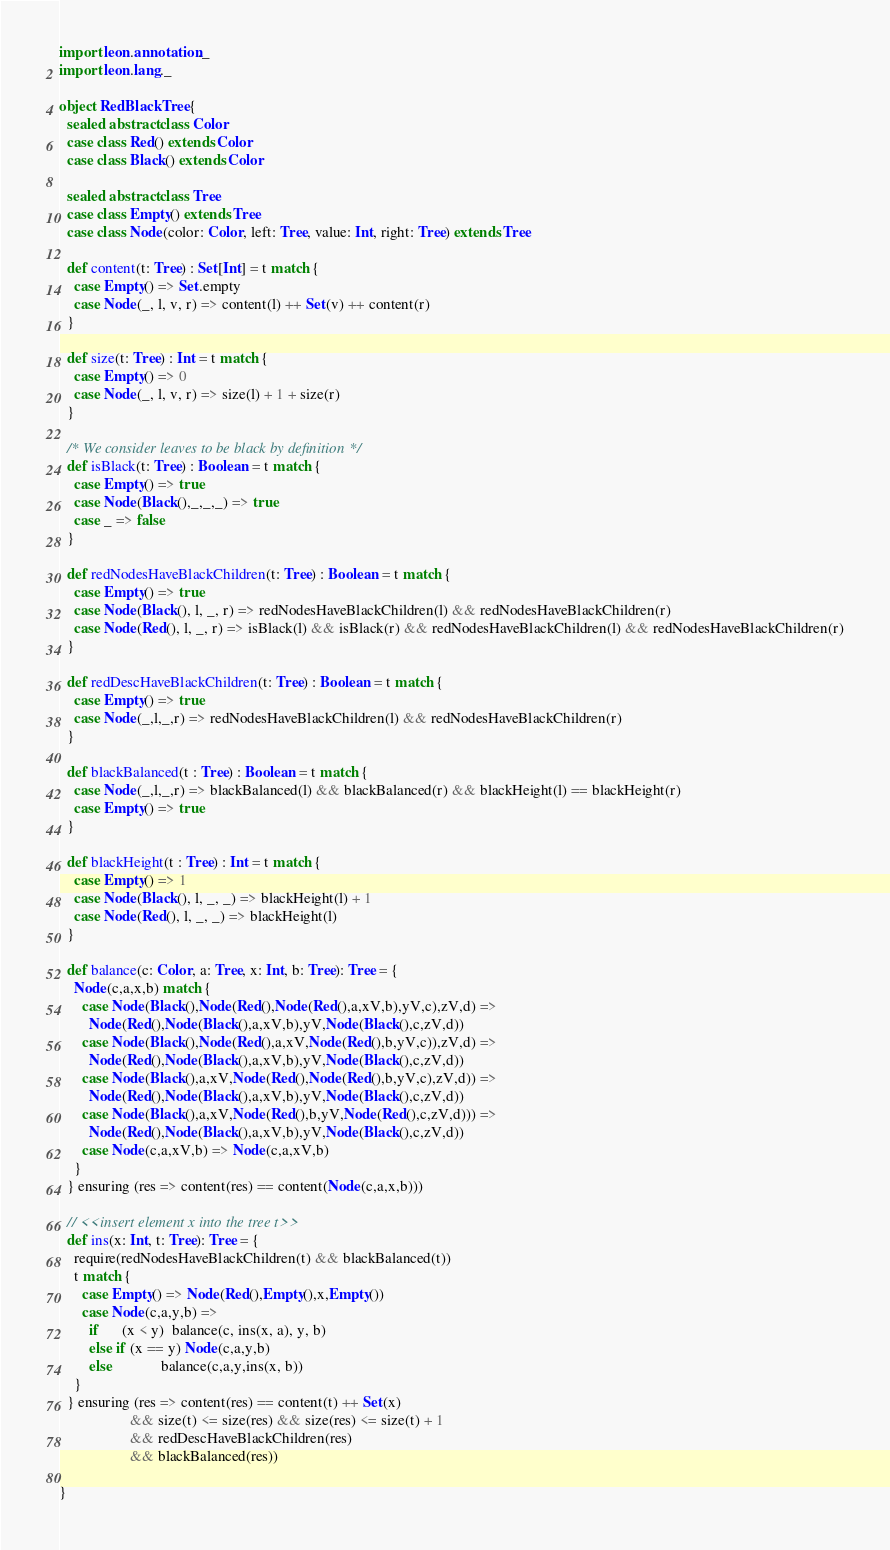<code> <loc_0><loc_0><loc_500><loc_500><_Scala_>import leon.annotation._
import leon.lang._

object RedBlackTree { 
  sealed abstract class Color
  case class Red() extends Color
  case class Black() extends Color
 
  sealed abstract class Tree
  case class Empty() extends Tree
  case class Node(color: Color, left: Tree, value: Int, right: Tree) extends Tree

  def content(t: Tree) : Set[Int] = t match {
    case Empty() => Set.empty
    case Node(_, l, v, r) => content(l) ++ Set(v) ++ content(r)
  }

  def size(t: Tree) : Int = t match {
    case Empty() => 0
    case Node(_, l, v, r) => size(l) + 1 + size(r)
  }

  /* We consider leaves to be black by definition */
  def isBlack(t: Tree) : Boolean = t match {
    case Empty() => true
    case Node(Black(),_,_,_) => true
    case _ => false
  }

  def redNodesHaveBlackChildren(t: Tree) : Boolean = t match {
    case Empty() => true
    case Node(Black(), l, _, r) => redNodesHaveBlackChildren(l) && redNodesHaveBlackChildren(r)
    case Node(Red(), l, _, r) => isBlack(l) && isBlack(r) && redNodesHaveBlackChildren(l) && redNodesHaveBlackChildren(r)
  }

  def redDescHaveBlackChildren(t: Tree) : Boolean = t match {
    case Empty() => true
    case Node(_,l,_,r) => redNodesHaveBlackChildren(l) && redNodesHaveBlackChildren(r)
  }

  def blackBalanced(t : Tree) : Boolean = t match {
    case Node(_,l,_,r) => blackBalanced(l) && blackBalanced(r) && blackHeight(l) == blackHeight(r)
    case Empty() => true
  }

  def blackHeight(t : Tree) : Int = t match {
    case Empty() => 1
    case Node(Black(), l, _, _) => blackHeight(l) + 1
    case Node(Red(), l, _, _) => blackHeight(l)
  }
  
  def balance(c: Color, a: Tree, x: Int, b: Tree): Tree = {
    Node(c,a,x,b) match {
      case Node(Black(),Node(Red(),Node(Red(),a,xV,b),yV,c),zV,d) => 
        Node(Red(),Node(Black(),a,xV,b),yV,Node(Black(),c,zV,d))
      case Node(Black(),Node(Red(),a,xV,Node(Red(),b,yV,c)),zV,d) => 
        Node(Red(),Node(Black(),a,xV,b),yV,Node(Black(),c,zV,d))
      case Node(Black(),a,xV,Node(Red(),Node(Red(),b,yV,c),zV,d)) => 
        Node(Red(),Node(Black(),a,xV,b),yV,Node(Black(),c,zV,d))
      case Node(Black(),a,xV,Node(Red(),b,yV,Node(Red(),c,zV,d))) => 
        Node(Red(),Node(Black(),a,xV,b),yV,Node(Black(),c,zV,d))
      case Node(c,a,xV,b) => Node(c,a,xV,b)
    }
  } ensuring (res => content(res) == content(Node(c,a,x,b)))

  // <<insert element x into the tree t>>
  def ins(x: Int, t: Tree): Tree = {
    require(redNodesHaveBlackChildren(t) && blackBalanced(t))
    t match {
      case Empty() => Node(Red(),Empty(),x,Empty())
      case Node(c,a,y,b) =>
        if      (x < y)  balance(c, ins(x, a), y, b)
        else if (x == y) Node(c,a,y,b)
        else             balance(c,a,y,ins(x, b))
    }
  } ensuring (res => content(res) == content(t) ++ Set(x) 
                   && size(t) <= size(res) && size(res) <= size(t) + 1
                   && redDescHaveBlackChildren(res)
                   && blackBalanced(res))

}
</code> 